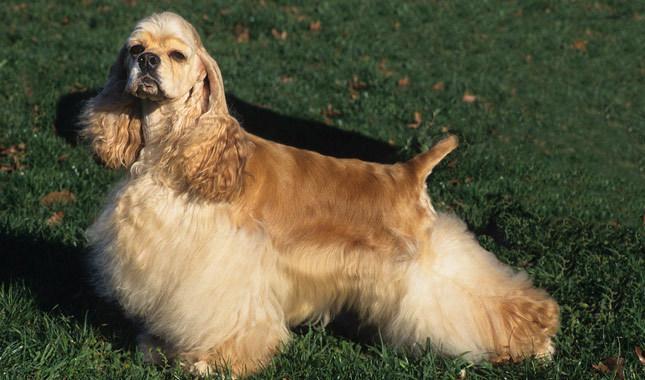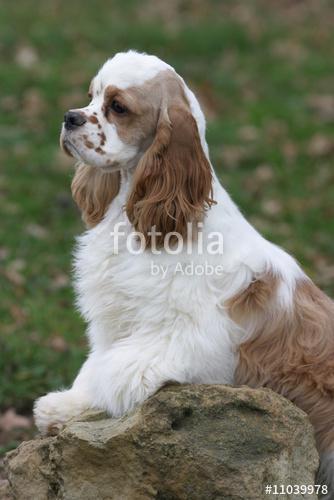The first image is the image on the left, the second image is the image on the right. For the images shown, is this caption "The left image shows a spaniel with its body in profile." true? Answer yes or no. Yes. 